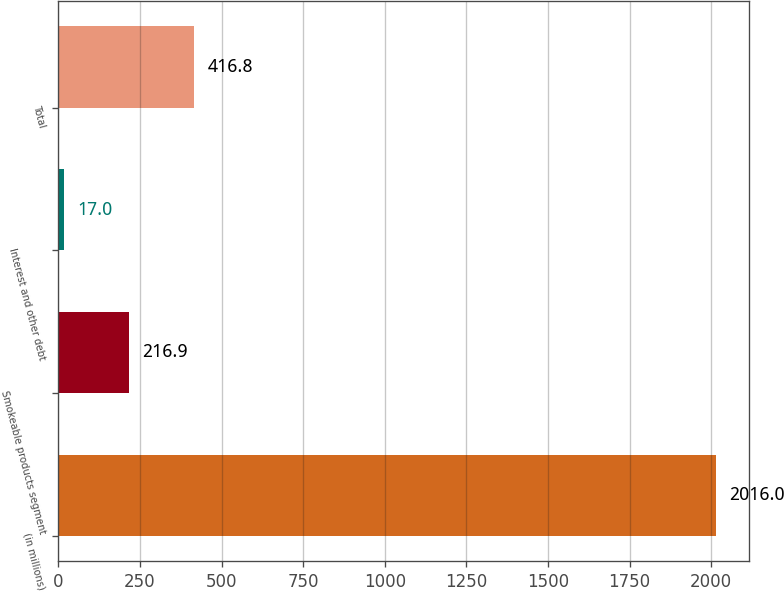Convert chart. <chart><loc_0><loc_0><loc_500><loc_500><bar_chart><fcel>(in millions)<fcel>Smokeable products segment<fcel>Interest and other debt<fcel>Total<nl><fcel>2016<fcel>216.9<fcel>17<fcel>416.8<nl></chart> 